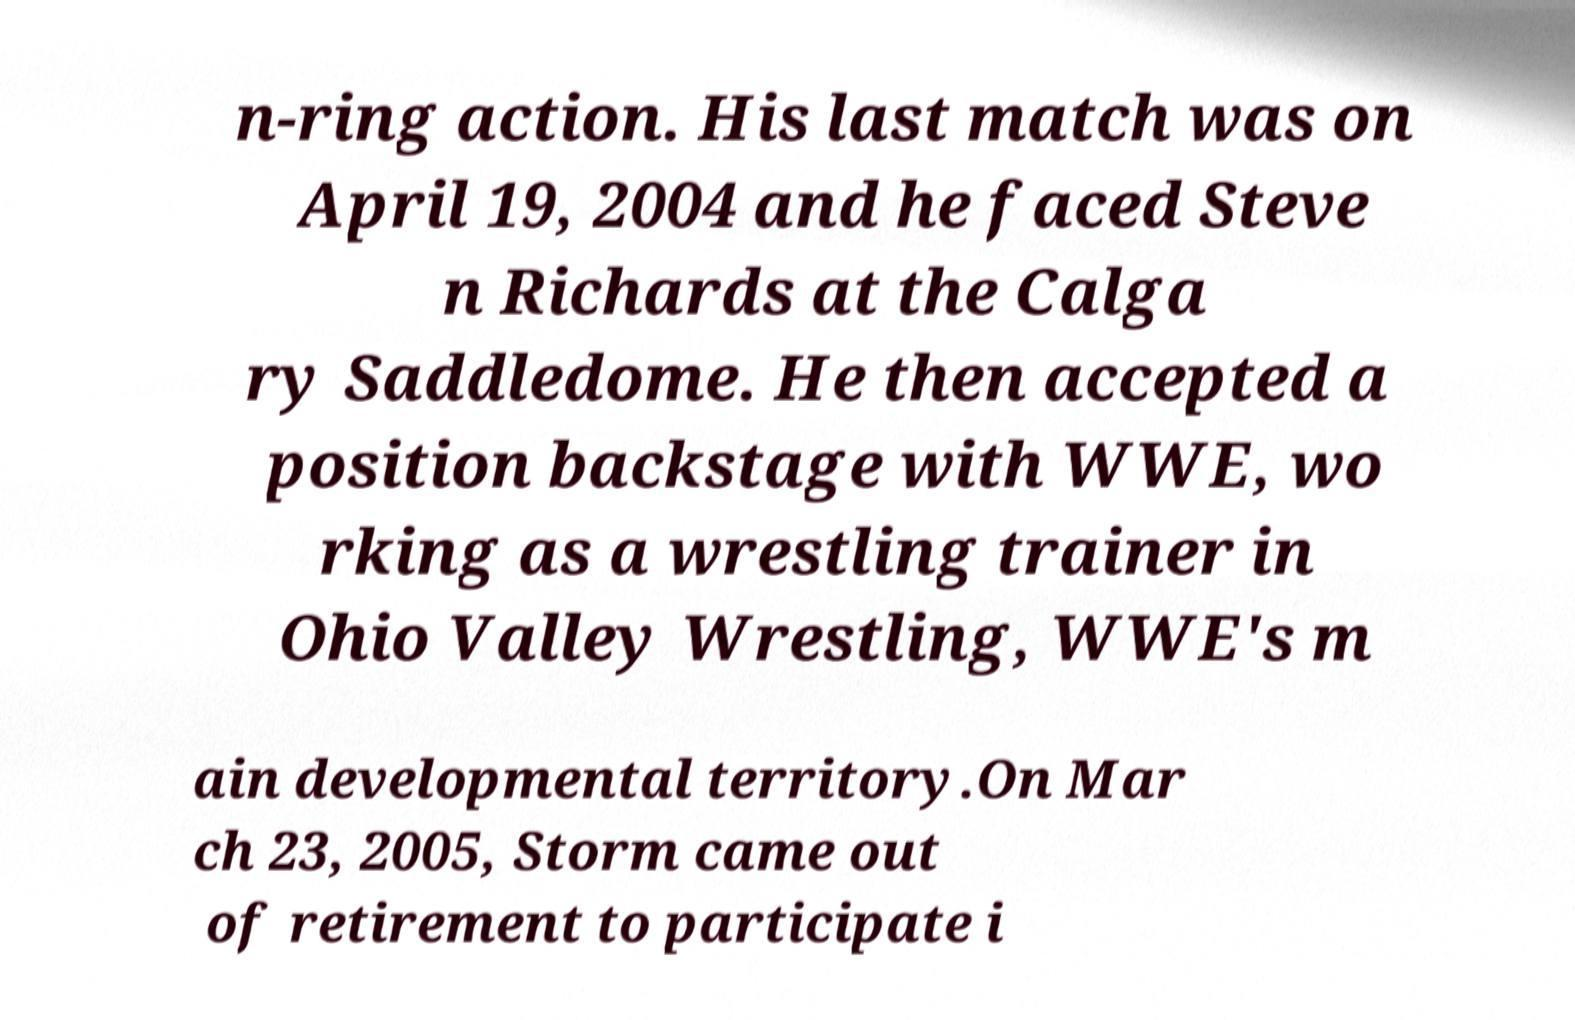What messages or text are displayed in this image? I need them in a readable, typed format. n-ring action. His last match was on April 19, 2004 and he faced Steve n Richards at the Calga ry Saddledome. He then accepted a position backstage with WWE, wo rking as a wrestling trainer in Ohio Valley Wrestling, WWE's m ain developmental territory.On Mar ch 23, 2005, Storm came out of retirement to participate i 